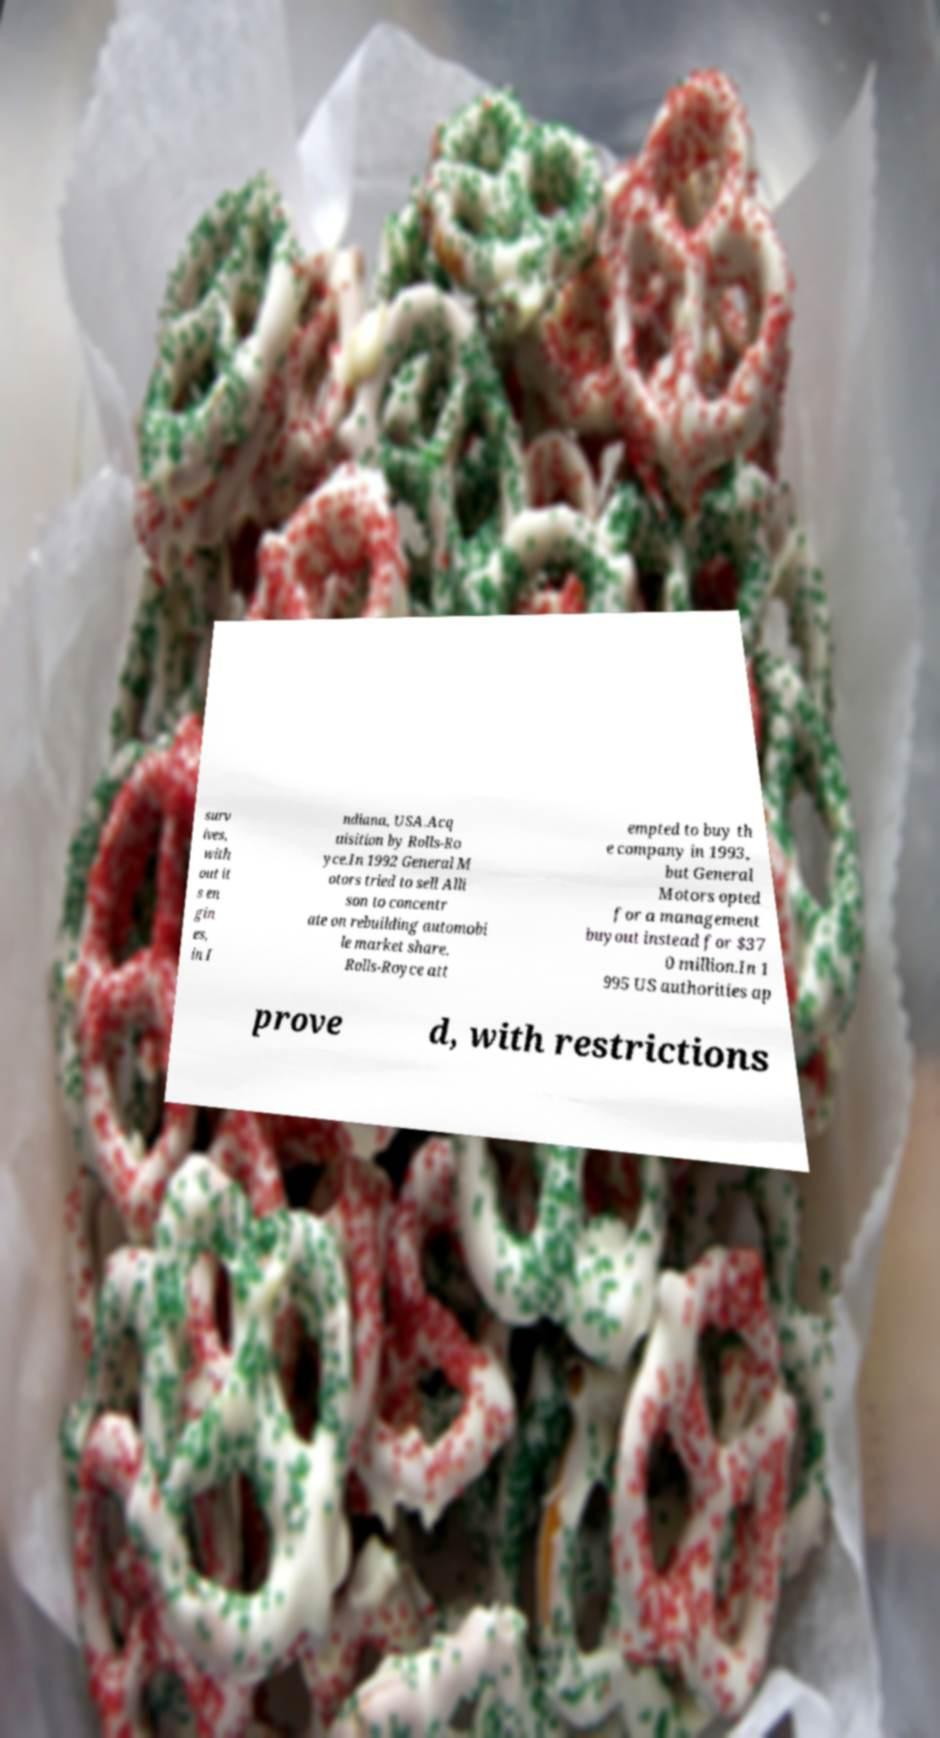Could you assist in decoding the text presented in this image and type it out clearly? surv ives, with out it s en gin es, in I ndiana, USA.Acq uisition by Rolls-Ro yce.In 1992 General M otors tried to sell Alli son to concentr ate on rebuilding automobi le market share. Rolls-Royce att empted to buy th e company in 1993, but General Motors opted for a management buyout instead for $37 0 million.In 1 995 US authorities ap prove d, with restrictions 